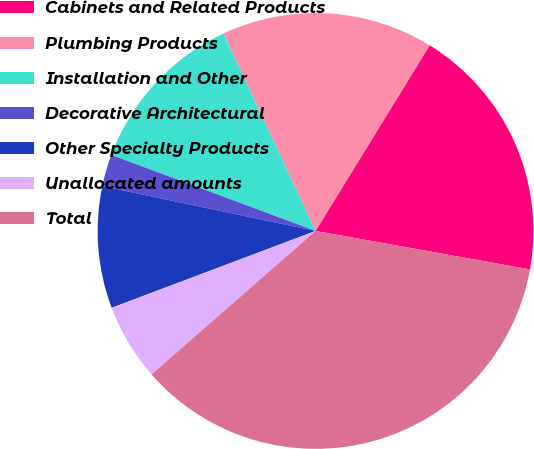Convert chart. <chart><loc_0><loc_0><loc_500><loc_500><pie_chart><fcel>Cabinets and Related Products<fcel>Plumbing Products<fcel>Installation and Other<fcel>Decorative Architectural<fcel>Other Specialty Products<fcel>Unallocated amounts<fcel>Total<nl><fcel>19.05%<fcel>15.72%<fcel>12.38%<fcel>2.37%<fcel>9.04%<fcel>5.7%<fcel>35.74%<nl></chart> 